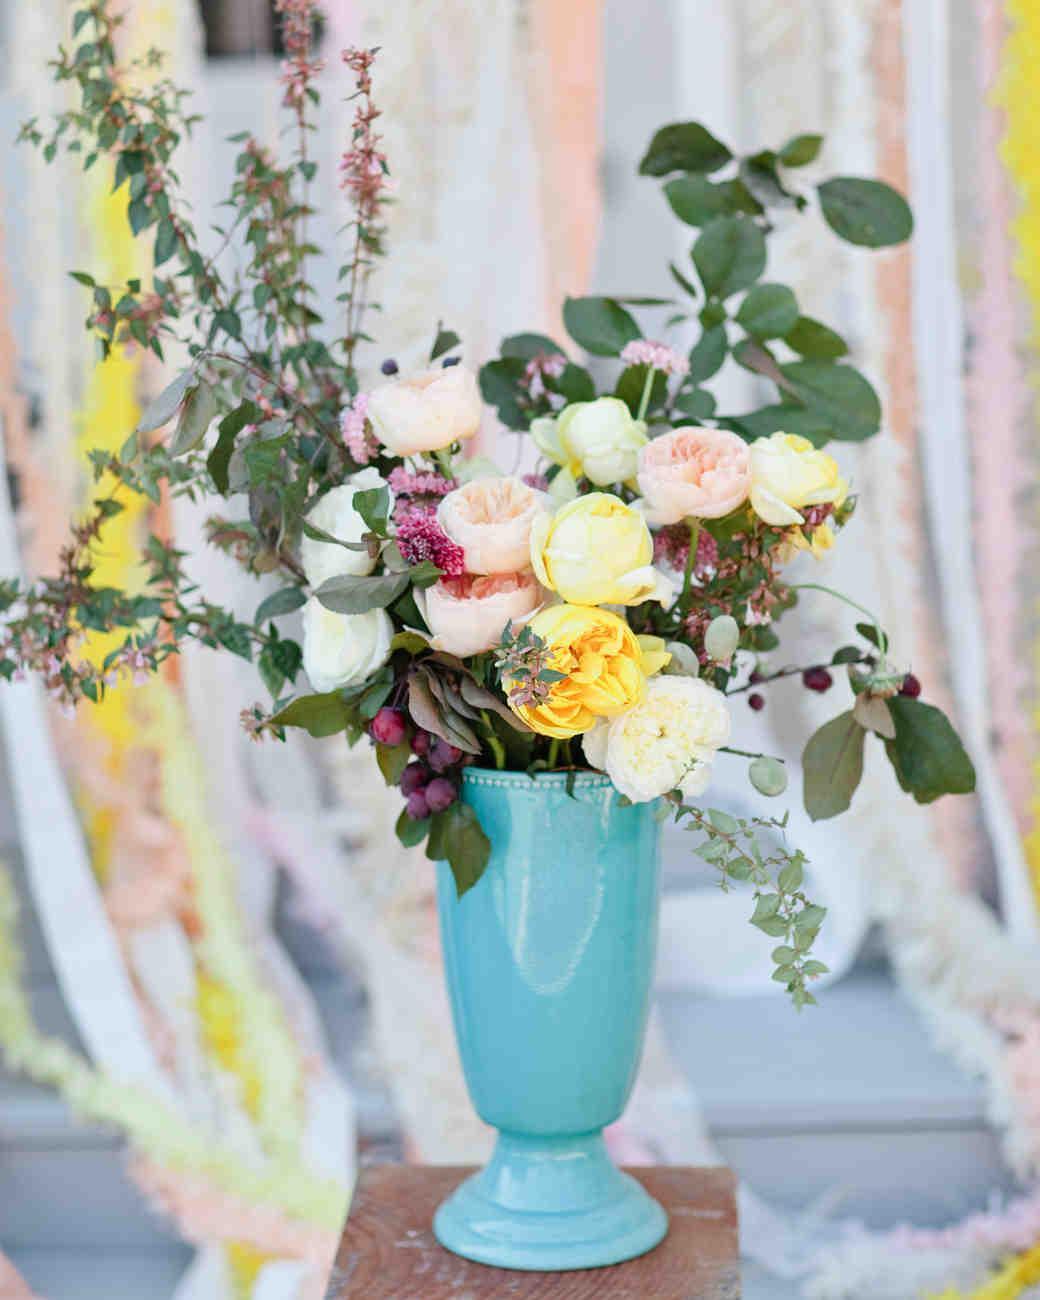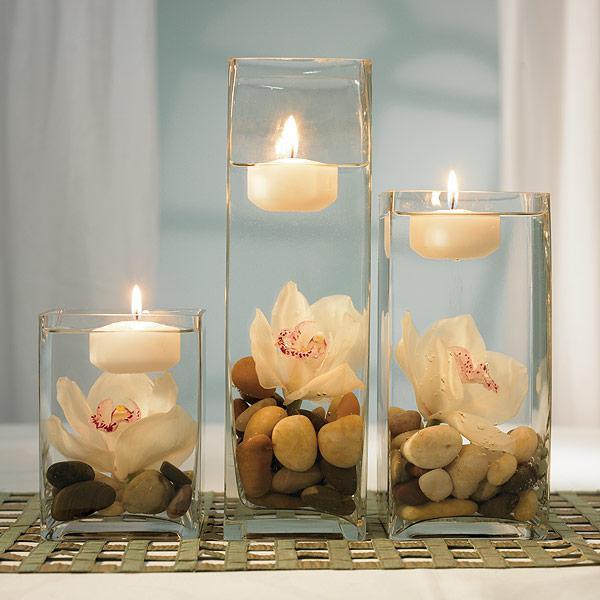The first image is the image on the left, the second image is the image on the right. Assess this claim about the two images: "there are lit candles in glass vases". Correct or not? Answer yes or no. Yes. 